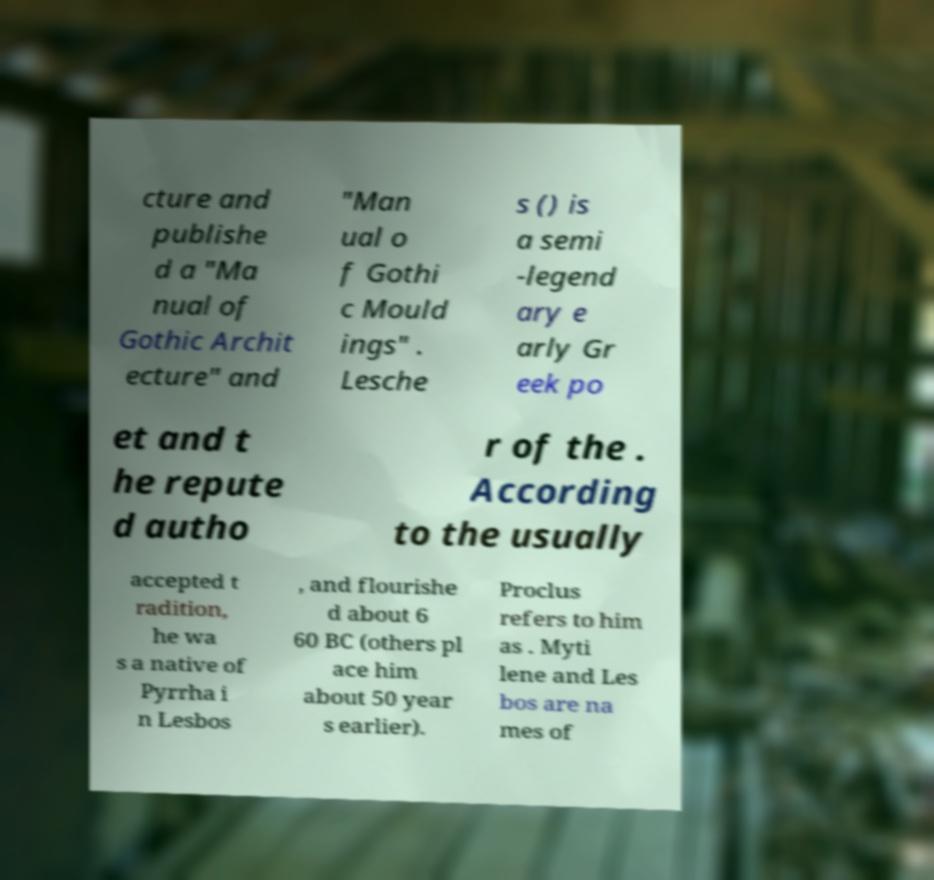Can you read and provide the text displayed in the image?This photo seems to have some interesting text. Can you extract and type it out for me? cture and publishe d a "Ma nual of Gothic Archit ecture" and "Man ual o f Gothi c Mould ings" . Lesche s () is a semi -legend ary e arly Gr eek po et and t he repute d autho r of the . According to the usually accepted t radition, he wa s a native of Pyrrha i n Lesbos , and flourishe d about 6 60 BC (others pl ace him about 50 year s earlier). Proclus refers to him as . Myti lene and Les bos are na mes of 